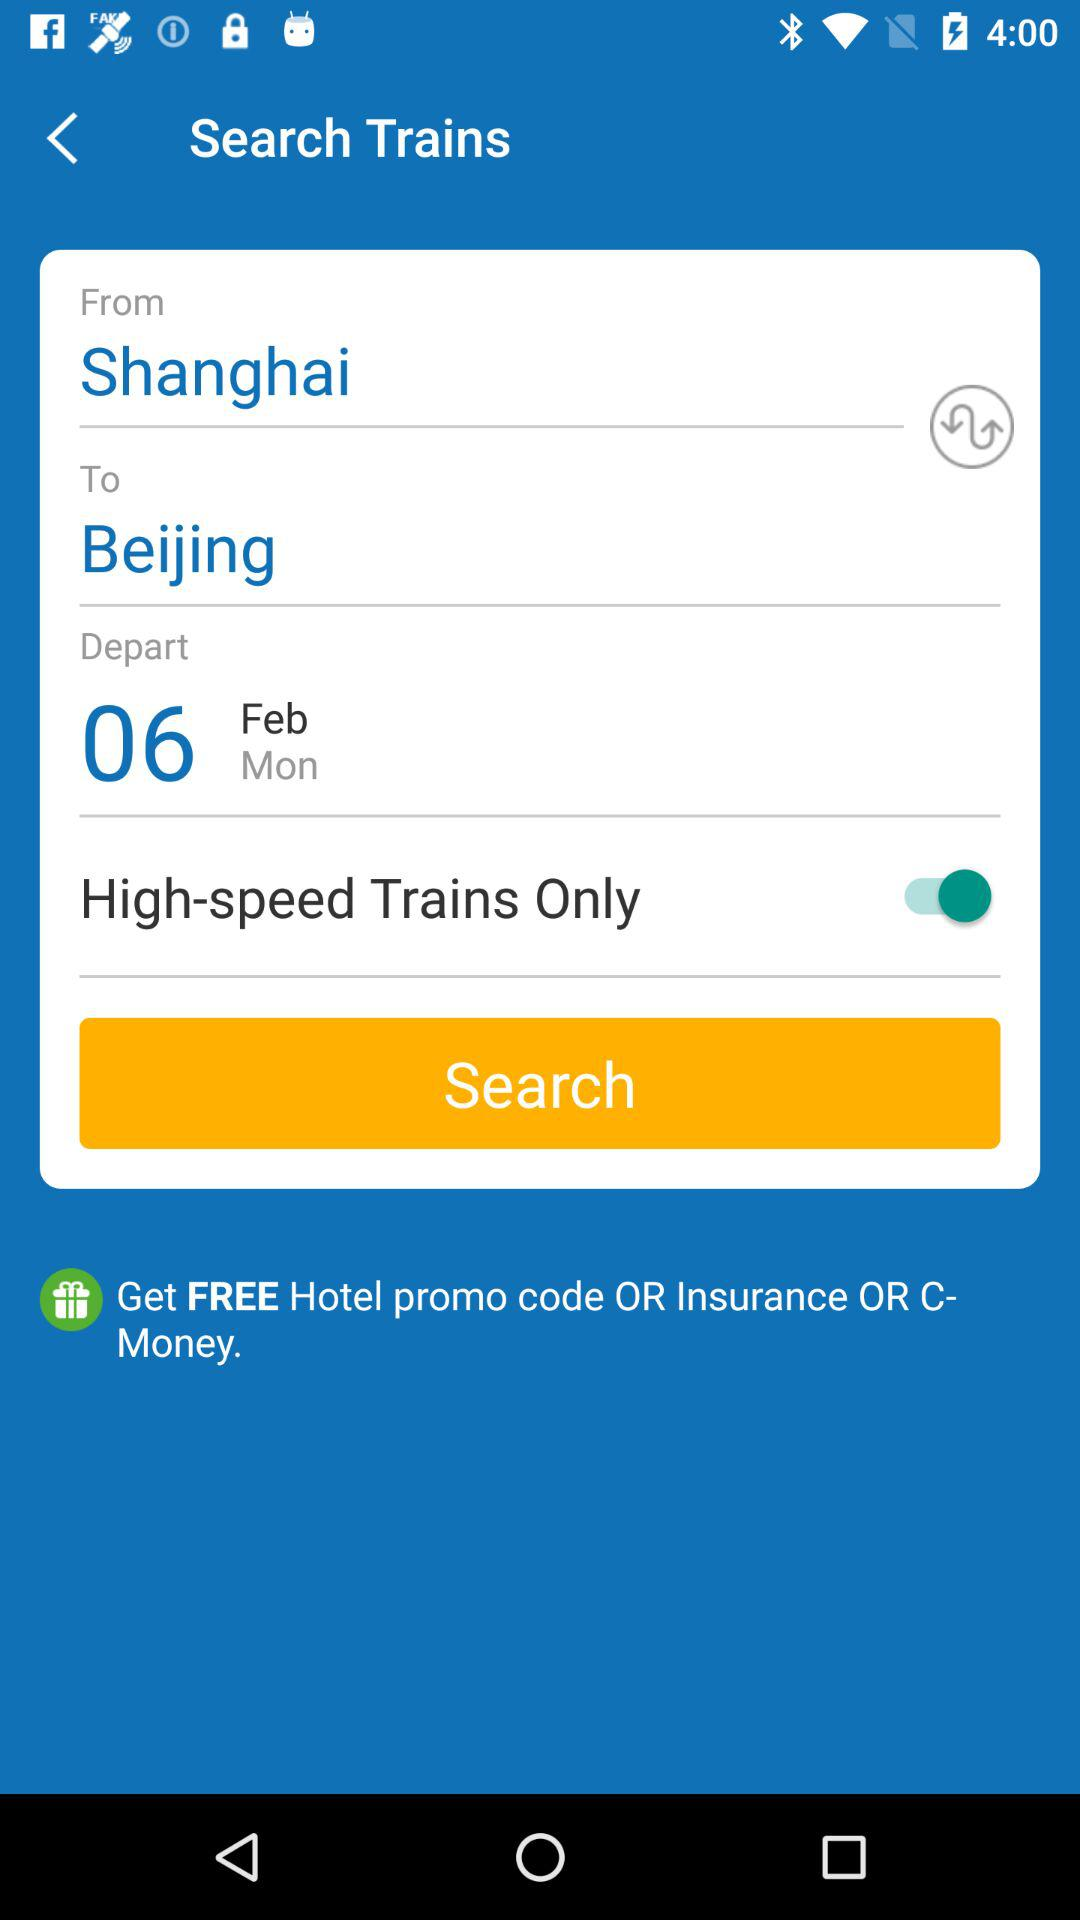What is the date of travel? The date of travel is Monday, February 6. 